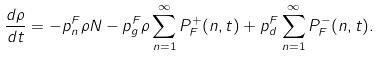<formula> <loc_0><loc_0><loc_500><loc_500>\frac { d \rho } { d t } = - p ^ { F } _ { n } \rho N - p ^ { F } _ { g } \rho \sum _ { n = 1 } ^ { \infty } P _ { F } ^ { + } ( n , t ) + p ^ { F } _ { d } \sum _ { n = 1 } ^ { \infty } P _ { F } ^ { - } ( n , t ) .</formula> 